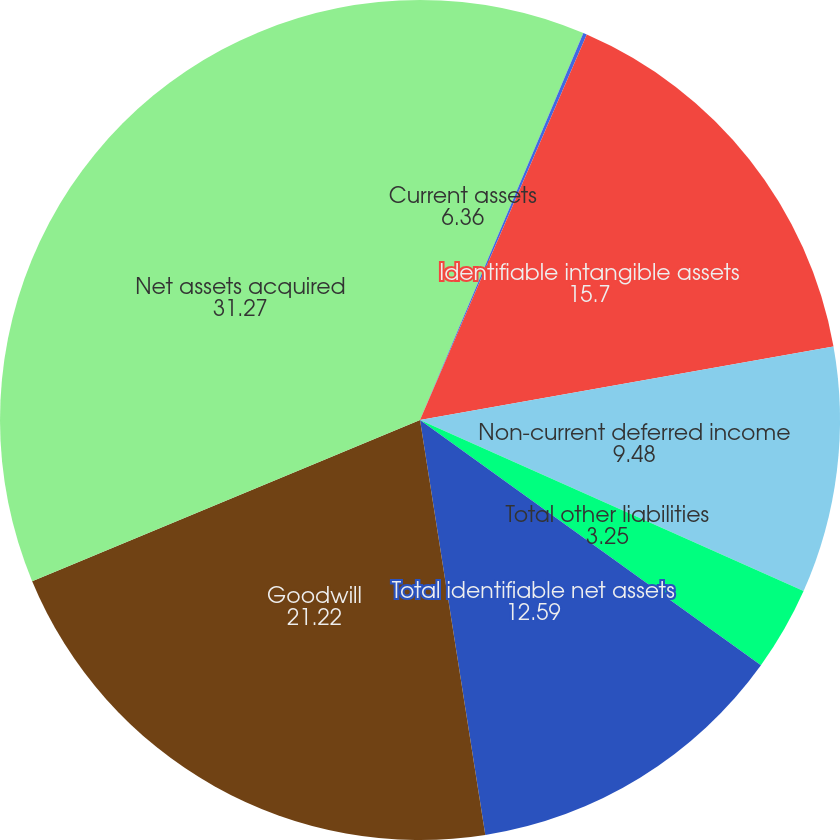Convert chart to OTSL. <chart><loc_0><loc_0><loc_500><loc_500><pie_chart><fcel>Current assets<fcel>Long-term assets<fcel>Identifiable intangible assets<fcel>Non-current deferred income<fcel>Total other liabilities<fcel>Total identifiable net assets<fcel>Goodwill<fcel>Net assets acquired<nl><fcel>6.36%<fcel>0.14%<fcel>15.7%<fcel>9.48%<fcel>3.25%<fcel>12.59%<fcel>21.22%<fcel>31.27%<nl></chart> 